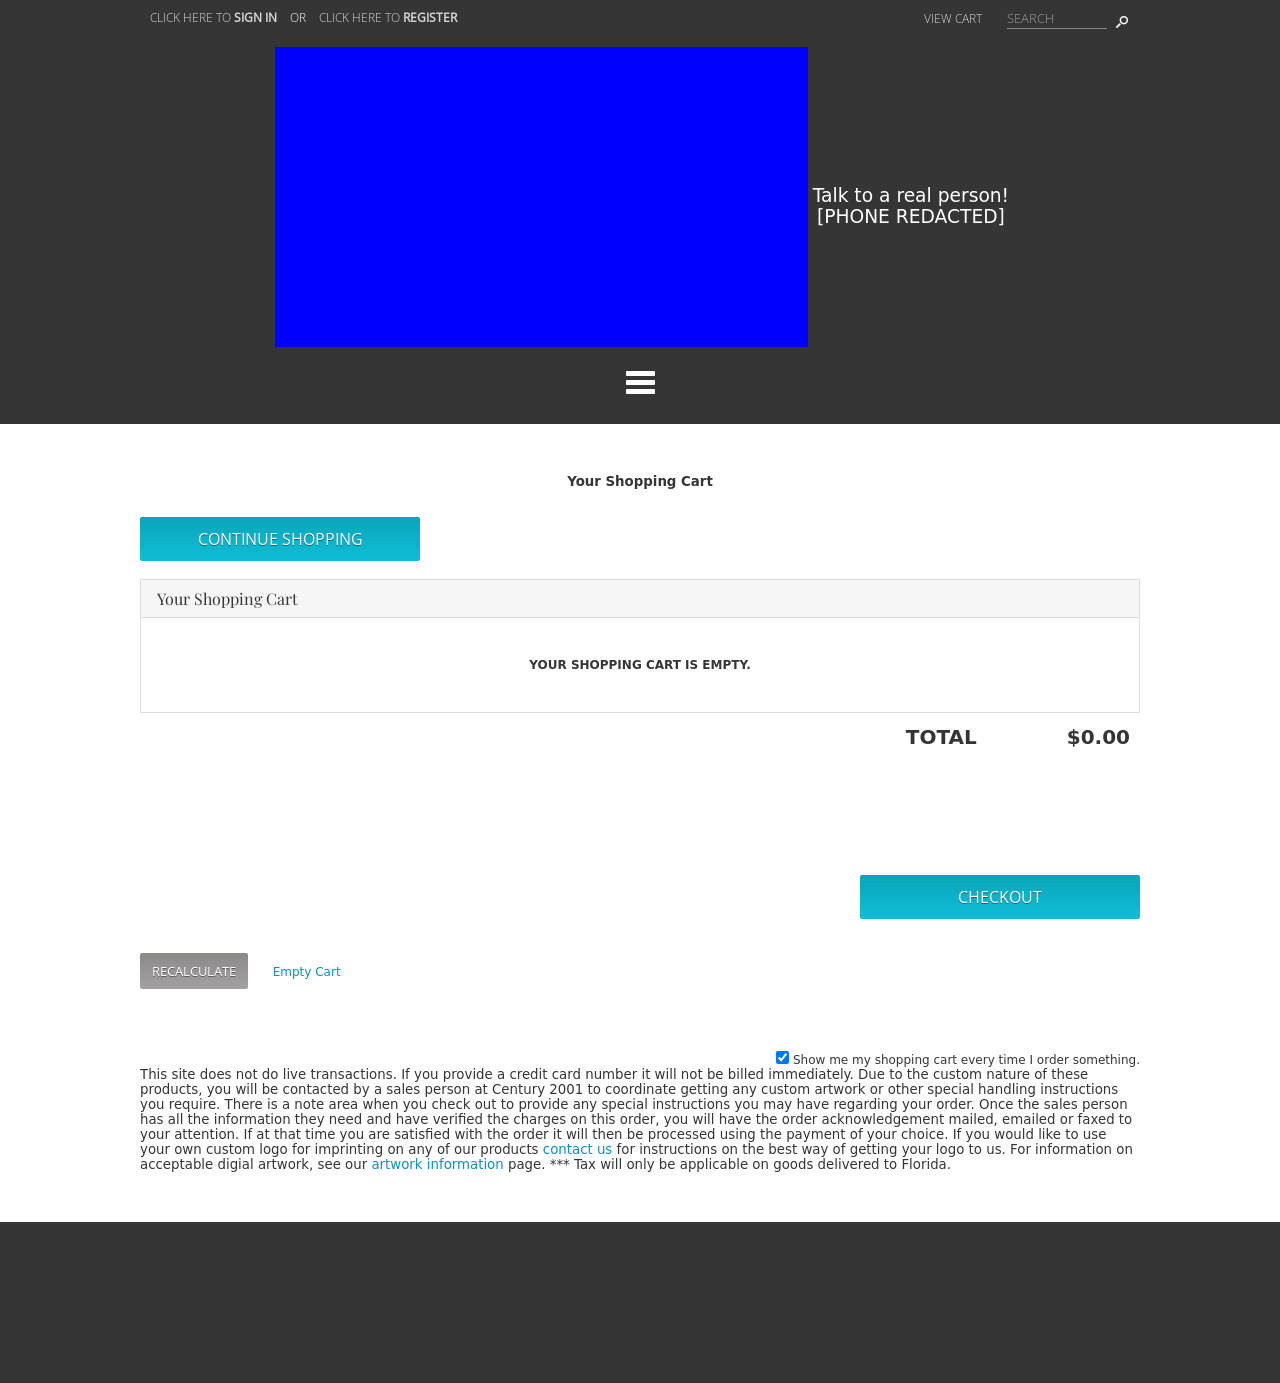How can I start building this website with HTML from the ground up? To start building a website with HTML from the ground up, begin by creating the basic structure using the <!DOCTYPE html>, <html>, <head>, and <body> tags. Use the <title> tag within the <head> section to specify the title of your website. Inside the <body>, you can start adding content using <h1> to <h6> for headings, <p> for paragraphs, <a> for links, <img> for images, and so forth. To style the website, link a CSS file within the <head> section using the <link rel='stylesheet' href='filename.css'> tag. Use various CSS properties to design your layout and present your content appealingly. 